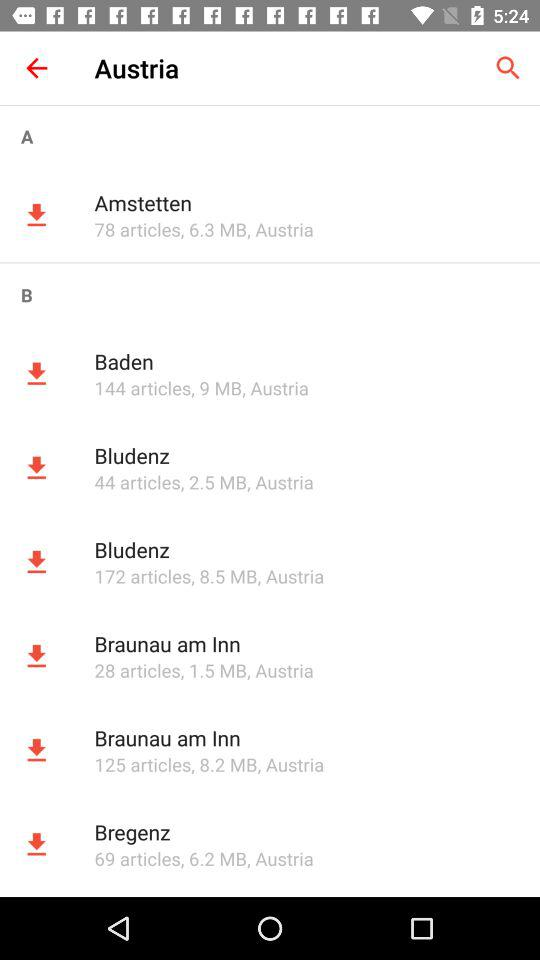How many articles are in the "Baden"? There are 144 articles in the "Baden". 